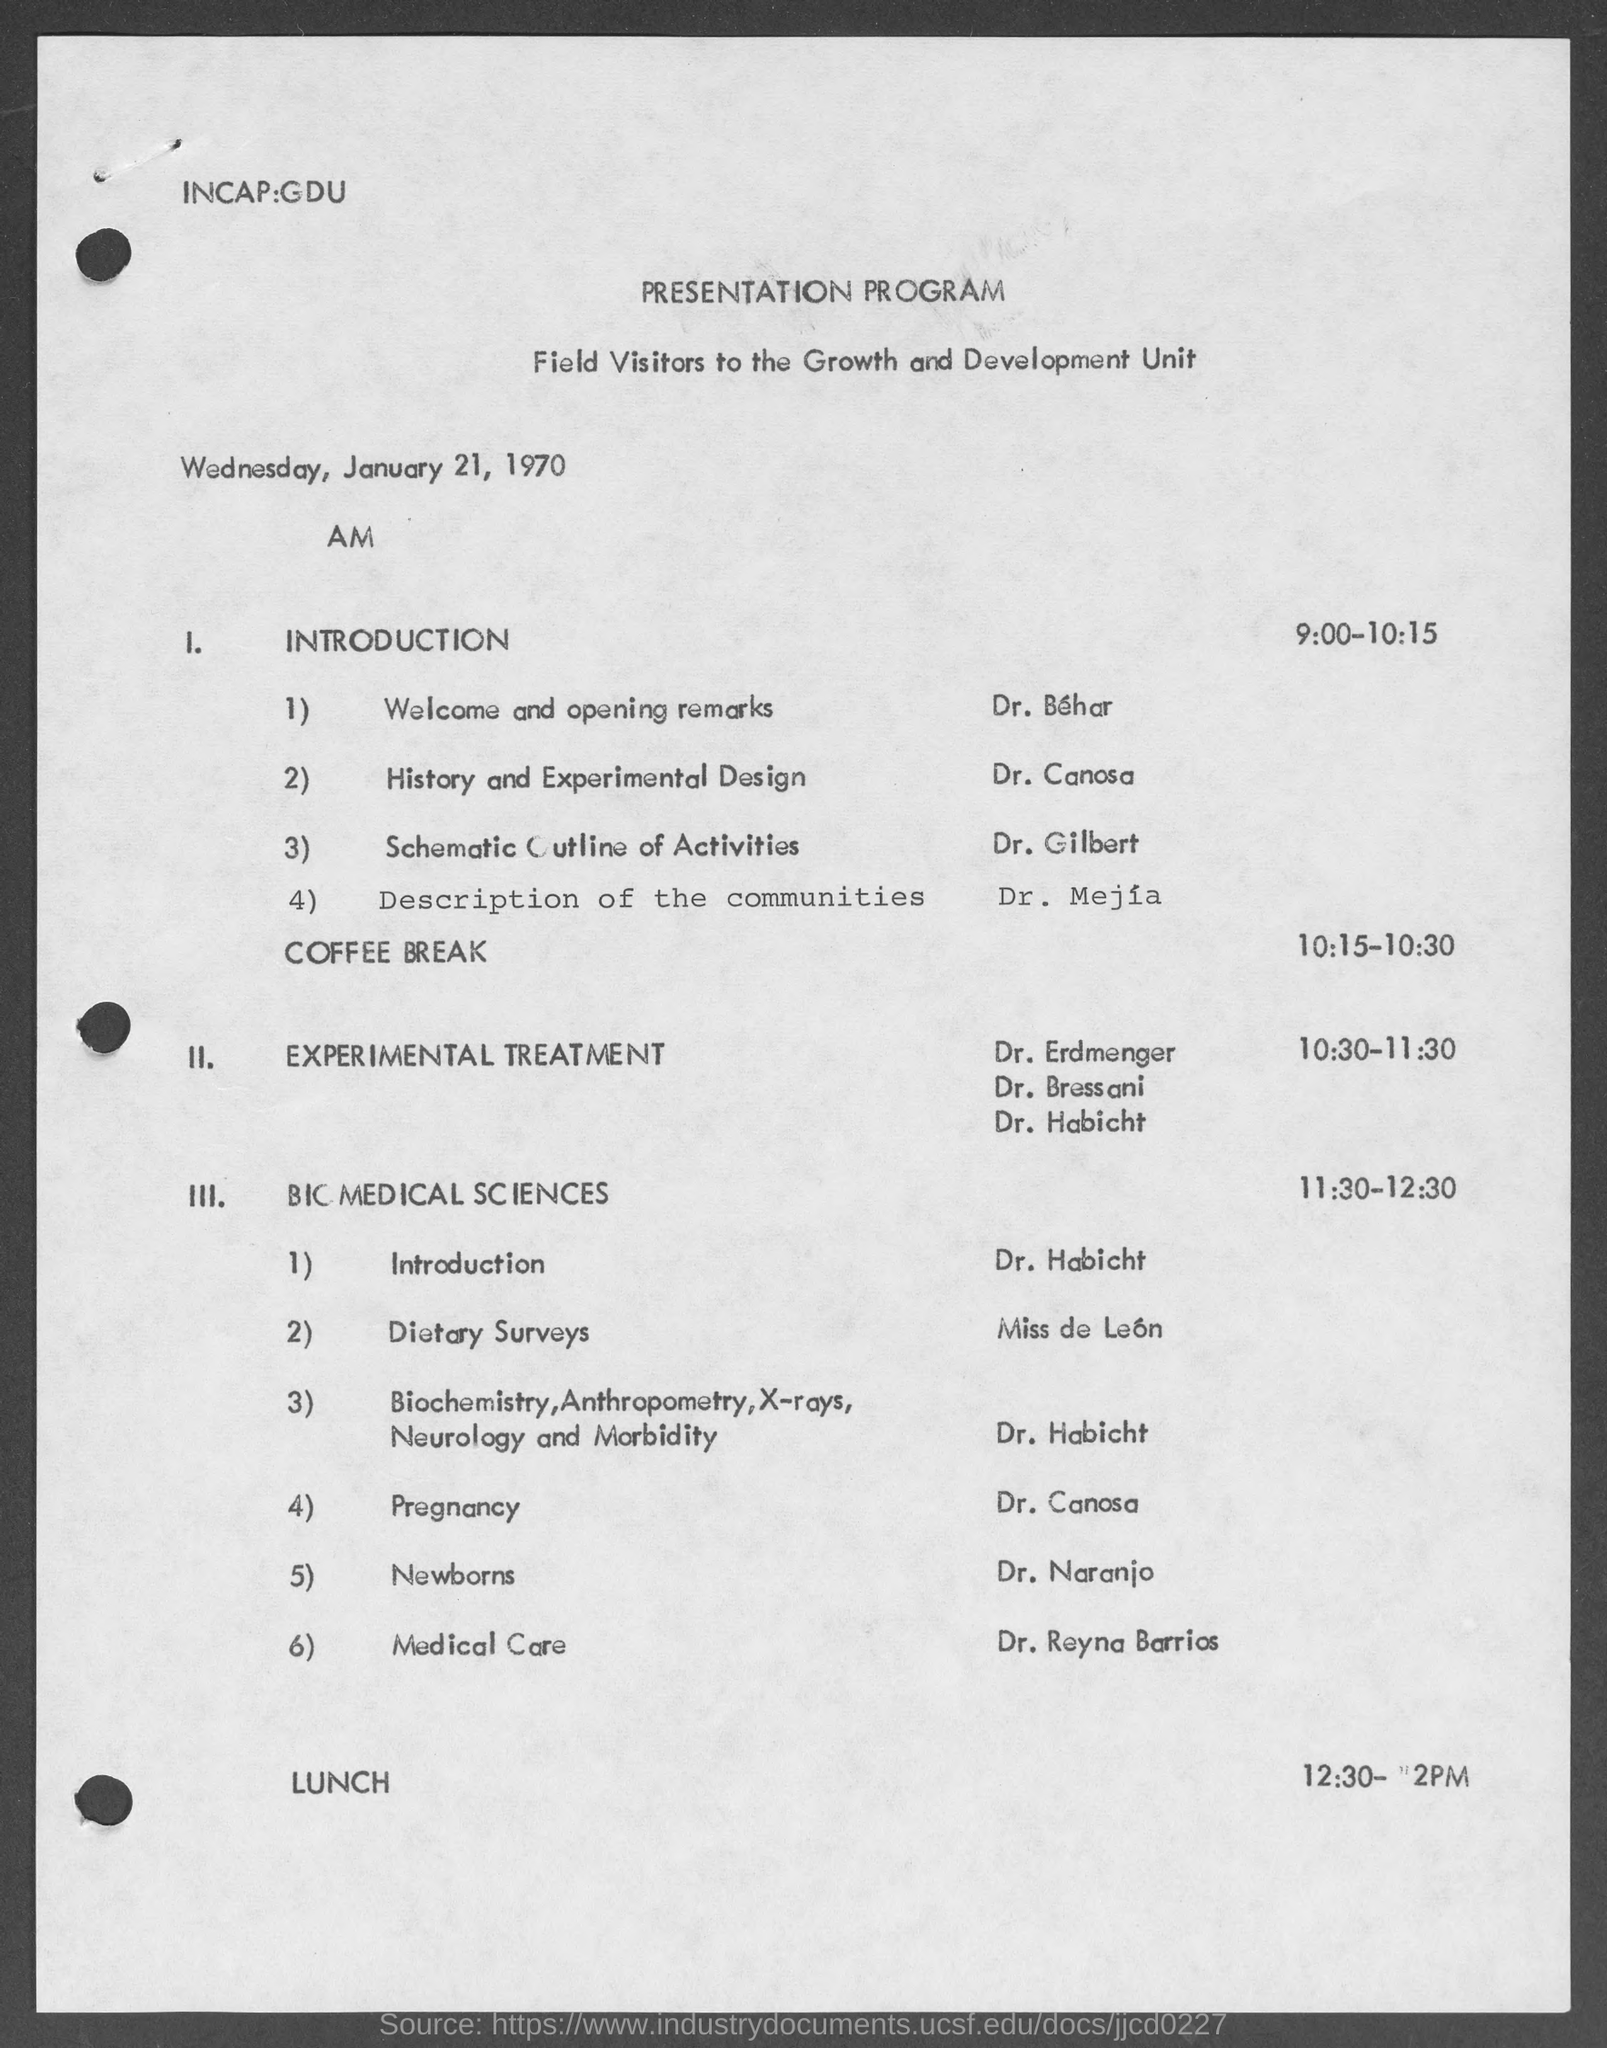What is the title at top of page?
Provide a succinct answer. Presentation Program. Who is giving history and experimental design?
Your response must be concise. Dr. Canosa. Who is giving schematic outline of activities ?
Offer a terse response. Dr. Gilbert. 